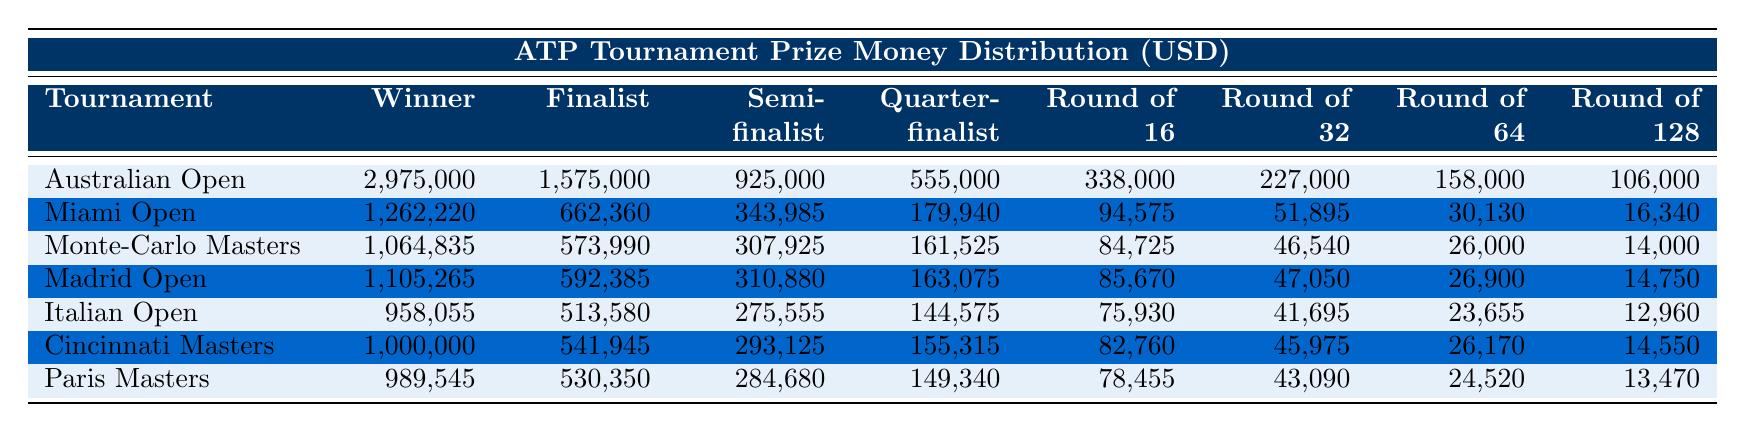What is the winner's prize for the Australian Open? The table indicates that the winner's prize for the Australian Open is listed under the "Winner Prize" column, which shows the amount as 2,975,000.
Answer: 2,975,000 What is the prize money for a Quarter-finalist at the Miami Open? Looking at the table, the Quarter-finalist Prize for the Miami Open is found in the corresponding row under the "Quarter-finalist Prize" column, which states it as 179,940.
Answer: 179,940 Which tournament offers the highest prize for the Semi-finalist? By comparing the Semi-finalist Prize amounts across all tournaments in the table, the Australian Open has the highest semi-finalist prize of 925,000.
Answer: Australian Open How much more does the winner of the Madrid Open earn compared to the Italian Open? To find out the difference, we subtract the winner's prize of the Italian Open (958,055) from that of the Madrid Open (1,105,265). The calculation is 1,105,265 - 958,055 = 147,210.
Answer: 147,210 What is the total prize money for a finalist in the Monte-Carlo Masters and Cincinnati Masters combined? The table indicates the Finalist Prize for the Monte-Carlo Masters is 573,990 and for the Cincinnati Masters is 541,945. Adding them together gives us 573,990 + 541,945 = 1,115,935.
Answer: 1,115,935 Do the Round of 16 prizes at the Cincinnati Masters and Paris Masters differ? By checking the table, the Round of 16 Prize for Cincinnati Masters is 82,760, while for the Paris Masters it is 78,455, which confirms that they do differ.
Answer: Yes What is the median prize money for a Quarter-finalist among all tournaments listed? First, we extract the Quarter-finalist Prizes: 555,000 (Australian Open), 179,940 (Miami Open), 161,525 (Monte-Carlo Masters), 163,075 (Madrid Open), 144,575 (Italian Open), 155,315 (Cincinnati Masters), and 149,340 (Paris Masters). Arranging them in order: 144,575, 155,315, 161,525, 163,075, 179,940, 555,000. Since there are 7 values (odd), the median is the middle value, which is 163,075.
Answer: 163,075 Which tournament has a Round of 128 prize money higher than 15,000? Each Round of 128 prize amount must be checked against 15,000. The Miami Open (16,340), Monte-Carlo Masters (14,000), and Madrid Open (14,750) have respective amounts. Among them, Miami Open is the only one exceeding 15,000.
Answer: Miami Open Are the Round of 32 prizes greater in the Madrid Open than in the Italian Open? From the table, the Round of 32 prize for Madrid Open is 47,050, while for Italian Open it is 41,695. Since 47,050 is greater than 41,695, the answer is affirmative.
Answer: Yes What is the total prize money for all levels in the Australian Open? To calculate, we sum all the prize amounts for the Australian Open: 2,975,000 + 1,575,000 + 925,000 + 555,000 + 338,000 + 227,000 + 158,000 + 106,000 = 6,959,000.
Answer: 6,959,000 